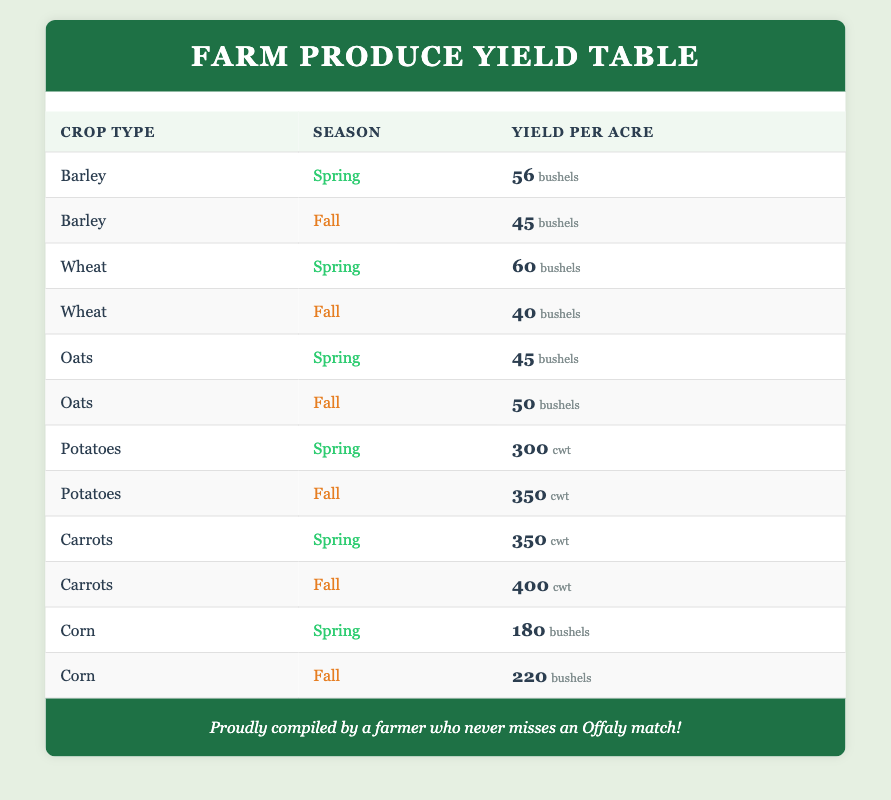What is the yield per acre of barley in spring? In the table, we look for the row where the crop type is "Barley" and the season is "Spring". The yield specified in that row is 56 bushels per acre.
Answer: 56 bushels Which crop has the highest yield in fall? To find the highest yield in the fall season, we check all the crops listed for the fall season. Potatoes yield 350 cwt, carrots yield 400 cwt, and corn yields 220 bushels. The carrot yield is the highest among these.
Answer: Carrots What is the total yield of oats in both seasons? We sum the yield of oats from both the spring (45 bushels) and fall (50 bushels) entries. The calculation is \(45 + 50 = 95\) bushels.
Answer: 95 bushels Is the yield of potatoes in the fall greater than the yield of wheat in the spring? To verify this, we compare the yield of potatoes in fall (350 cwt) and wheat in spring (60 bushels). Since 350 cwt is greater than 60 bushels, the statement is true.
Answer: Yes What is the average yield of corn across both seasons? The yield of corn is 180 bushels in spring and 220 bushels in fall. To find the average, we first sum the yields: \(180 + 220 = 400\) and then divide by 2, so the average is \(400 / 2 = 200\) bushels.
Answer: 200 bushels Which crop type has the lowest yield in the spring? We can examine all the spring yields: barley (56 bushels), wheat (60 bushels), oats (45 bushels), potatoes (300 cwt), carrots (350 cwt), and corn (180 bushels). The lowest yield is for oats at 45 bushels.
Answer: Oats Do more crops yield higher in fall than in spring? We must compare the yields of spring and fall for each crop type. For barley, wheat, and oats, the spring yield is higher, while for potatoes, carrots, and corn, the fall yield is higher. Specifically, both potatoes and carrots yield more in the fall. Therefore, more crops do not yield higher in fall.
Answer: No What is the difference in yield per acre between carrots in fall and corn in fall? The yield of carrots in fall is 400 cwt, and for corn in fall, it is 220 bushels. To find the difference, we convert both to the same unit. Since cwt is a higher measure than bushels, we leave them separate and find the difference: \(400 cwt - 220 bushels\). However, since they are not directly comparable without conversion, the exact difference in meaningful terms can't be stated directly.
Answer: Not directly comparable 